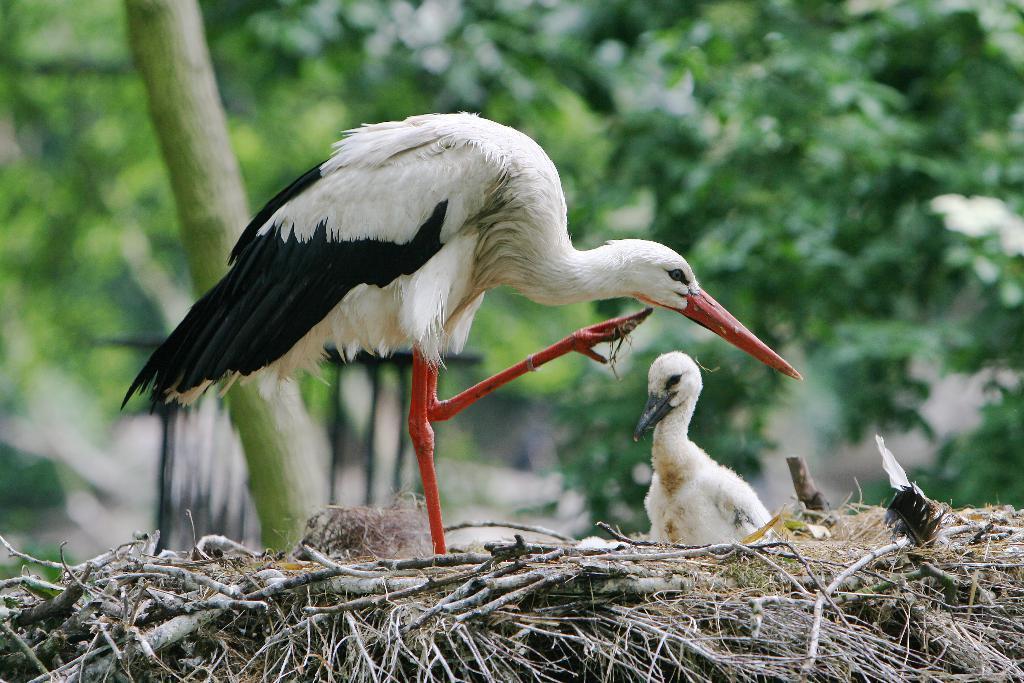Can you describe this image briefly? In this image I can see two birds, they are in white and black color. Background I can see trees in green color. 